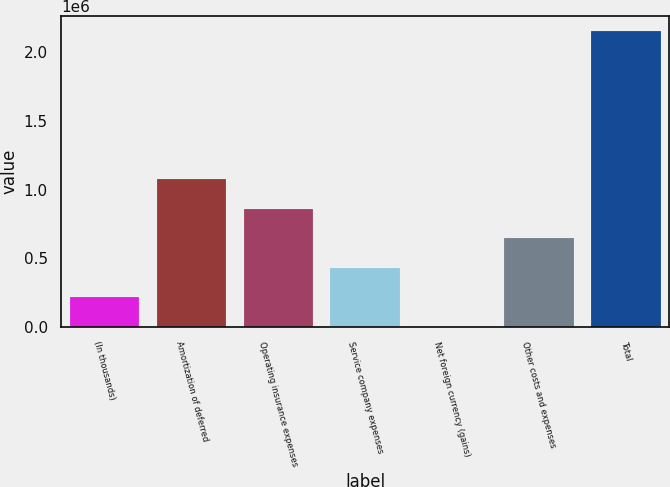<chart> <loc_0><loc_0><loc_500><loc_500><bar_chart><fcel>(In thousands)<fcel>Amortization of deferred<fcel>Operating insurance expenses<fcel>Service company expenses<fcel>Net foreign currency (gains)<fcel>Other costs and expenses<fcel>Total<nl><fcel>215770<fcel>1.07874e+06<fcel>862999<fcel>431513<fcel>27<fcel>647256<fcel>2.15746e+06<nl></chart> 